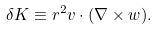Convert formula to latex. <formula><loc_0><loc_0><loc_500><loc_500>\delta K \equiv r ^ { 2 } v \cdot ( \nabla \times w ) .</formula> 